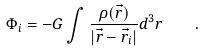<formula> <loc_0><loc_0><loc_500><loc_500>\Phi _ { i } = - G \int \frac { \rho ( \vec { r } ) } { | \vec { r } - \vec { r } _ { i } | } d ^ { 3 } r \quad .</formula> 